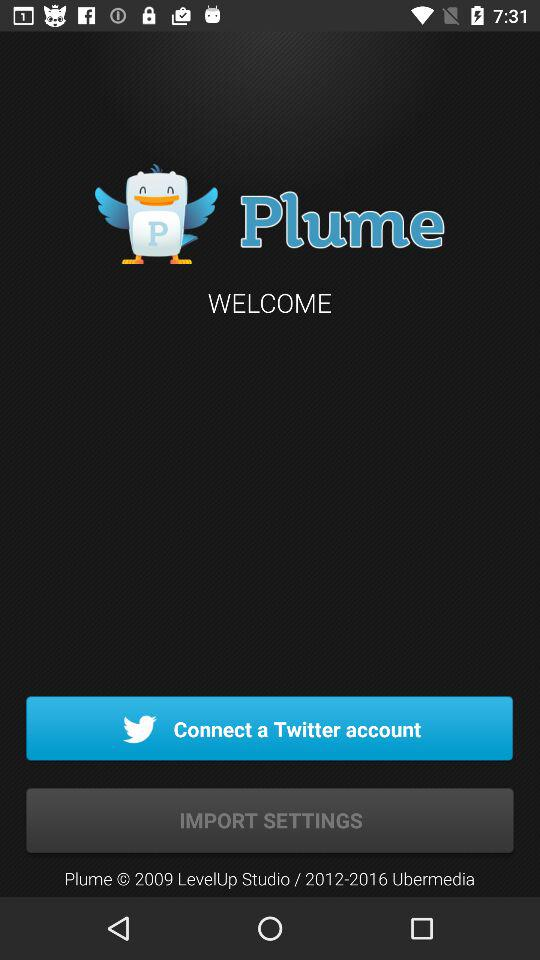Who is using "Plume"?
When the provided information is insufficient, respond with <no answer>. <no answer> 